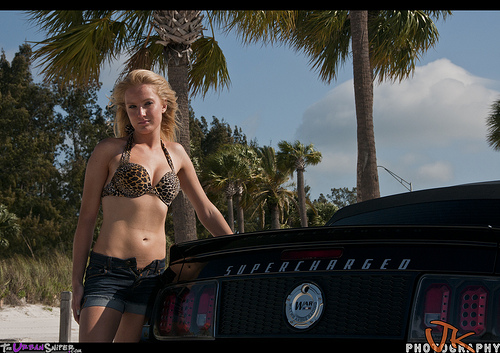<image>
Is the woman in the car? No. The woman is not contained within the car. These objects have a different spatial relationship. Where is the woman in relation to the sky? Is it in front of the sky? Yes. The woman is positioned in front of the sky, appearing closer to the camera viewpoint. 